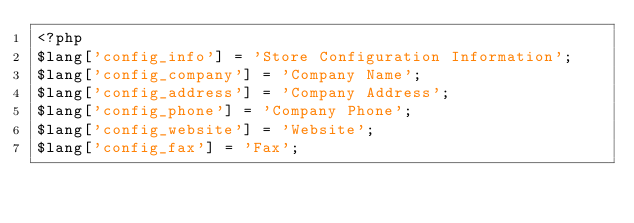<code> <loc_0><loc_0><loc_500><loc_500><_PHP_><?php
$lang['config_info'] = 'Store Configuration Information';
$lang['config_company'] = 'Company Name';
$lang['config_address'] = 'Company Address';
$lang['config_phone'] = 'Company Phone';
$lang['config_website'] = 'Website';
$lang['config_fax'] = 'Fax';</code> 